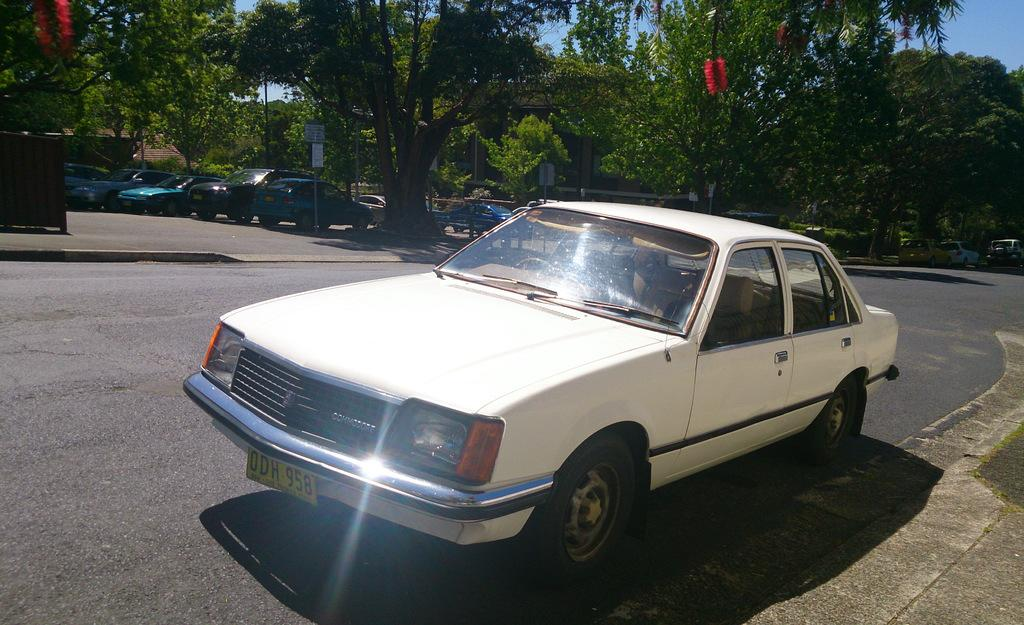What is the main subject in the front of the image? There is a car in the front of the image. What color is the car? The car is white in color. What can be seen in the background of the image? There are trees and vehicles in the background of the image. Can you describe the object visible in the image? Unfortunately, the provided facts do not give enough information to describe the object in detail. What type of glue is being used to hold the school together in the image? There is no school or glue present in the image; it features a white car in the front and trees and vehicles in the background. 